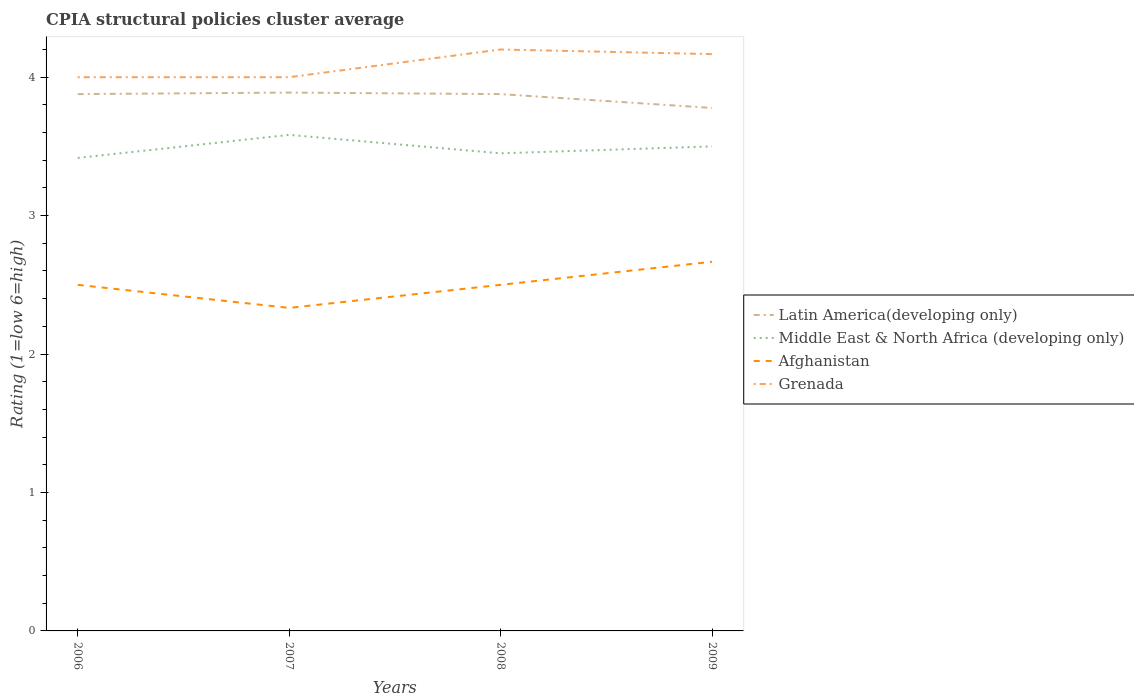How many different coloured lines are there?
Provide a short and direct response. 4. Is the number of lines equal to the number of legend labels?
Ensure brevity in your answer.  Yes. Across all years, what is the maximum CPIA rating in Grenada?
Make the answer very short. 4. In which year was the CPIA rating in Grenada maximum?
Your answer should be very brief. 2006. What is the total CPIA rating in Grenada in the graph?
Your answer should be very brief. -0.17. What is the difference between the highest and the second highest CPIA rating in Grenada?
Ensure brevity in your answer.  0.2. How many lines are there?
Your response must be concise. 4. Are the values on the major ticks of Y-axis written in scientific E-notation?
Offer a terse response. No. Does the graph contain grids?
Provide a succinct answer. No. How many legend labels are there?
Your answer should be compact. 4. How are the legend labels stacked?
Provide a short and direct response. Vertical. What is the title of the graph?
Offer a terse response. CPIA structural policies cluster average. What is the label or title of the X-axis?
Your response must be concise. Years. What is the Rating (1=low 6=high) in Latin America(developing only) in 2006?
Keep it short and to the point. 3.88. What is the Rating (1=low 6=high) in Middle East & North Africa (developing only) in 2006?
Your response must be concise. 3.42. What is the Rating (1=low 6=high) of Grenada in 2006?
Make the answer very short. 4. What is the Rating (1=low 6=high) in Latin America(developing only) in 2007?
Ensure brevity in your answer.  3.89. What is the Rating (1=low 6=high) of Middle East & North Africa (developing only) in 2007?
Your answer should be very brief. 3.58. What is the Rating (1=low 6=high) of Afghanistan in 2007?
Keep it short and to the point. 2.33. What is the Rating (1=low 6=high) in Latin America(developing only) in 2008?
Keep it short and to the point. 3.88. What is the Rating (1=low 6=high) of Middle East & North Africa (developing only) in 2008?
Offer a very short reply. 3.45. What is the Rating (1=low 6=high) of Grenada in 2008?
Provide a short and direct response. 4.2. What is the Rating (1=low 6=high) in Latin America(developing only) in 2009?
Offer a very short reply. 3.78. What is the Rating (1=low 6=high) of Afghanistan in 2009?
Offer a very short reply. 2.67. What is the Rating (1=low 6=high) of Grenada in 2009?
Make the answer very short. 4.17. Across all years, what is the maximum Rating (1=low 6=high) in Latin America(developing only)?
Your response must be concise. 3.89. Across all years, what is the maximum Rating (1=low 6=high) in Middle East & North Africa (developing only)?
Make the answer very short. 3.58. Across all years, what is the maximum Rating (1=low 6=high) in Afghanistan?
Keep it short and to the point. 2.67. Across all years, what is the maximum Rating (1=low 6=high) of Grenada?
Provide a short and direct response. 4.2. Across all years, what is the minimum Rating (1=low 6=high) of Latin America(developing only)?
Your response must be concise. 3.78. Across all years, what is the minimum Rating (1=low 6=high) of Middle East & North Africa (developing only)?
Make the answer very short. 3.42. Across all years, what is the minimum Rating (1=low 6=high) of Afghanistan?
Make the answer very short. 2.33. What is the total Rating (1=low 6=high) of Latin America(developing only) in the graph?
Offer a terse response. 15.42. What is the total Rating (1=low 6=high) in Middle East & North Africa (developing only) in the graph?
Your answer should be compact. 13.95. What is the total Rating (1=low 6=high) of Afghanistan in the graph?
Provide a short and direct response. 10. What is the total Rating (1=low 6=high) in Grenada in the graph?
Offer a very short reply. 16.37. What is the difference between the Rating (1=low 6=high) of Latin America(developing only) in 2006 and that in 2007?
Provide a short and direct response. -0.01. What is the difference between the Rating (1=low 6=high) in Middle East & North Africa (developing only) in 2006 and that in 2007?
Your response must be concise. -0.17. What is the difference between the Rating (1=low 6=high) in Latin America(developing only) in 2006 and that in 2008?
Your response must be concise. 0. What is the difference between the Rating (1=low 6=high) in Middle East & North Africa (developing only) in 2006 and that in 2008?
Offer a terse response. -0.03. What is the difference between the Rating (1=low 6=high) of Afghanistan in 2006 and that in 2008?
Offer a very short reply. 0. What is the difference between the Rating (1=low 6=high) of Middle East & North Africa (developing only) in 2006 and that in 2009?
Provide a short and direct response. -0.08. What is the difference between the Rating (1=low 6=high) in Afghanistan in 2006 and that in 2009?
Your answer should be very brief. -0.17. What is the difference between the Rating (1=low 6=high) of Latin America(developing only) in 2007 and that in 2008?
Provide a short and direct response. 0.01. What is the difference between the Rating (1=low 6=high) in Middle East & North Africa (developing only) in 2007 and that in 2008?
Make the answer very short. 0.13. What is the difference between the Rating (1=low 6=high) of Grenada in 2007 and that in 2008?
Offer a very short reply. -0.2. What is the difference between the Rating (1=low 6=high) of Middle East & North Africa (developing only) in 2007 and that in 2009?
Provide a succinct answer. 0.08. What is the difference between the Rating (1=low 6=high) in Afghanistan in 2007 and that in 2009?
Make the answer very short. -0.33. What is the difference between the Rating (1=low 6=high) in Middle East & North Africa (developing only) in 2008 and that in 2009?
Provide a short and direct response. -0.05. What is the difference between the Rating (1=low 6=high) of Latin America(developing only) in 2006 and the Rating (1=low 6=high) of Middle East & North Africa (developing only) in 2007?
Your answer should be very brief. 0.29. What is the difference between the Rating (1=low 6=high) of Latin America(developing only) in 2006 and the Rating (1=low 6=high) of Afghanistan in 2007?
Keep it short and to the point. 1.54. What is the difference between the Rating (1=low 6=high) in Latin America(developing only) in 2006 and the Rating (1=low 6=high) in Grenada in 2007?
Give a very brief answer. -0.12. What is the difference between the Rating (1=low 6=high) of Middle East & North Africa (developing only) in 2006 and the Rating (1=low 6=high) of Grenada in 2007?
Provide a succinct answer. -0.58. What is the difference between the Rating (1=low 6=high) of Afghanistan in 2006 and the Rating (1=low 6=high) of Grenada in 2007?
Offer a very short reply. -1.5. What is the difference between the Rating (1=low 6=high) in Latin America(developing only) in 2006 and the Rating (1=low 6=high) in Middle East & North Africa (developing only) in 2008?
Your answer should be compact. 0.43. What is the difference between the Rating (1=low 6=high) of Latin America(developing only) in 2006 and the Rating (1=low 6=high) of Afghanistan in 2008?
Your answer should be compact. 1.38. What is the difference between the Rating (1=low 6=high) in Latin America(developing only) in 2006 and the Rating (1=low 6=high) in Grenada in 2008?
Your response must be concise. -0.32. What is the difference between the Rating (1=low 6=high) of Middle East & North Africa (developing only) in 2006 and the Rating (1=low 6=high) of Afghanistan in 2008?
Make the answer very short. 0.92. What is the difference between the Rating (1=low 6=high) of Middle East & North Africa (developing only) in 2006 and the Rating (1=low 6=high) of Grenada in 2008?
Provide a succinct answer. -0.78. What is the difference between the Rating (1=low 6=high) in Latin America(developing only) in 2006 and the Rating (1=low 6=high) in Middle East & North Africa (developing only) in 2009?
Provide a short and direct response. 0.38. What is the difference between the Rating (1=low 6=high) in Latin America(developing only) in 2006 and the Rating (1=low 6=high) in Afghanistan in 2009?
Your answer should be compact. 1.21. What is the difference between the Rating (1=low 6=high) in Latin America(developing only) in 2006 and the Rating (1=low 6=high) in Grenada in 2009?
Make the answer very short. -0.29. What is the difference between the Rating (1=low 6=high) of Middle East & North Africa (developing only) in 2006 and the Rating (1=low 6=high) of Grenada in 2009?
Your answer should be compact. -0.75. What is the difference between the Rating (1=low 6=high) of Afghanistan in 2006 and the Rating (1=low 6=high) of Grenada in 2009?
Offer a very short reply. -1.67. What is the difference between the Rating (1=low 6=high) in Latin America(developing only) in 2007 and the Rating (1=low 6=high) in Middle East & North Africa (developing only) in 2008?
Provide a succinct answer. 0.44. What is the difference between the Rating (1=low 6=high) of Latin America(developing only) in 2007 and the Rating (1=low 6=high) of Afghanistan in 2008?
Provide a succinct answer. 1.39. What is the difference between the Rating (1=low 6=high) of Latin America(developing only) in 2007 and the Rating (1=low 6=high) of Grenada in 2008?
Ensure brevity in your answer.  -0.31. What is the difference between the Rating (1=low 6=high) of Middle East & North Africa (developing only) in 2007 and the Rating (1=low 6=high) of Grenada in 2008?
Your answer should be very brief. -0.62. What is the difference between the Rating (1=low 6=high) of Afghanistan in 2007 and the Rating (1=low 6=high) of Grenada in 2008?
Your answer should be compact. -1.87. What is the difference between the Rating (1=low 6=high) of Latin America(developing only) in 2007 and the Rating (1=low 6=high) of Middle East & North Africa (developing only) in 2009?
Your answer should be compact. 0.39. What is the difference between the Rating (1=low 6=high) of Latin America(developing only) in 2007 and the Rating (1=low 6=high) of Afghanistan in 2009?
Give a very brief answer. 1.22. What is the difference between the Rating (1=low 6=high) of Latin America(developing only) in 2007 and the Rating (1=low 6=high) of Grenada in 2009?
Offer a very short reply. -0.28. What is the difference between the Rating (1=low 6=high) of Middle East & North Africa (developing only) in 2007 and the Rating (1=low 6=high) of Grenada in 2009?
Your answer should be compact. -0.58. What is the difference between the Rating (1=low 6=high) in Afghanistan in 2007 and the Rating (1=low 6=high) in Grenada in 2009?
Offer a very short reply. -1.83. What is the difference between the Rating (1=low 6=high) of Latin America(developing only) in 2008 and the Rating (1=low 6=high) of Middle East & North Africa (developing only) in 2009?
Your response must be concise. 0.38. What is the difference between the Rating (1=low 6=high) of Latin America(developing only) in 2008 and the Rating (1=low 6=high) of Afghanistan in 2009?
Provide a succinct answer. 1.21. What is the difference between the Rating (1=low 6=high) in Latin America(developing only) in 2008 and the Rating (1=low 6=high) in Grenada in 2009?
Your answer should be very brief. -0.29. What is the difference between the Rating (1=low 6=high) of Middle East & North Africa (developing only) in 2008 and the Rating (1=low 6=high) of Afghanistan in 2009?
Your answer should be compact. 0.78. What is the difference between the Rating (1=low 6=high) in Middle East & North Africa (developing only) in 2008 and the Rating (1=low 6=high) in Grenada in 2009?
Your answer should be very brief. -0.72. What is the difference between the Rating (1=low 6=high) in Afghanistan in 2008 and the Rating (1=low 6=high) in Grenada in 2009?
Provide a succinct answer. -1.67. What is the average Rating (1=low 6=high) of Latin America(developing only) per year?
Offer a very short reply. 3.86. What is the average Rating (1=low 6=high) of Middle East & North Africa (developing only) per year?
Offer a terse response. 3.49. What is the average Rating (1=low 6=high) of Grenada per year?
Give a very brief answer. 4.09. In the year 2006, what is the difference between the Rating (1=low 6=high) in Latin America(developing only) and Rating (1=low 6=high) in Middle East & North Africa (developing only)?
Give a very brief answer. 0.46. In the year 2006, what is the difference between the Rating (1=low 6=high) of Latin America(developing only) and Rating (1=low 6=high) of Afghanistan?
Provide a short and direct response. 1.38. In the year 2006, what is the difference between the Rating (1=low 6=high) of Latin America(developing only) and Rating (1=low 6=high) of Grenada?
Provide a short and direct response. -0.12. In the year 2006, what is the difference between the Rating (1=low 6=high) of Middle East & North Africa (developing only) and Rating (1=low 6=high) of Afghanistan?
Provide a short and direct response. 0.92. In the year 2006, what is the difference between the Rating (1=low 6=high) of Middle East & North Africa (developing only) and Rating (1=low 6=high) of Grenada?
Provide a succinct answer. -0.58. In the year 2006, what is the difference between the Rating (1=low 6=high) in Afghanistan and Rating (1=low 6=high) in Grenada?
Make the answer very short. -1.5. In the year 2007, what is the difference between the Rating (1=low 6=high) of Latin America(developing only) and Rating (1=low 6=high) of Middle East & North Africa (developing only)?
Your answer should be compact. 0.31. In the year 2007, what is the difference between the Rating (1=low 6=high) in Latin America(developing only) and Rating (1=low 6=high) in Afghanistan?
Your answer should be very brief. 1.56. In the year 2007, what is the difference between the Rating (1=low 6=high) in Latin America(developing only) and Rating (1=low 6=high) in Grenada?
Your answer should be compact. -0.11. In the year 2007, what is the difference between the Rating (1=low 6=high) of Middle East & North Africa (developing only) and Rating (1=low 6=high) of Grenada?
Your answer should be very brief. -0.42. In the year 2007, what is the difference between the Rating (1=low 6=high) in Afghanistan and Rating (1=low 6=high) in Grenada?
Provide a succinct answer. -1.67. In the year 2008, what is the difference between the Rating (1=low 6=high) of Latin America(developing only) and Rating (1=low 6=high) of Middle East & North Africa (developing only)?
Offer a very short reply. 0.43. In the year 2008, what is the difference between the Rating (1=low 6=high) of Latin America(developing only) and Rating (1=low 6=high) of Afghanistan?
Provide a succinct answer. 1.38. In the year 2008, what is the difference between the Rating (1=low 6=high) of Latin America(developing only) and Rating (1=low 6=high) of Grenada?
Ensure brevity in your answer.  -0.32. In the year 2008, what is the difference between the Rating (1=low 6=high) in Middle East & North Africa (developing only) and Rating (1=low 6=high) in Afghanistan?
Give a very brief answer. 0.95. In the year 2008, what is the difference between the Rating (1=low 6=high) of Middle East & North Africa (developing only) and Rating (1=low 6=high) of Grenada?
Give a very brief answer. -0.75. In the year 2008, what is the difference between the Rating (1=low 6=high) of Afghanistan and Rating (1=low 6=high) of Grenada?
Your answer should be very brief. -1.7. In the year 2009, what is the difference between the Rating (1=low 6=high) in Latin America(developing only) and Rating (1=low 6=high) in Middle East & North Africa (developing only)?
Your response must be concise. 0.28. In the year 2009, what is the difference between the Rating (1=low 6=high) in Latin America(developing only) and Rating (1=low 6=high) in Grenada?
Make the answer very short. -0.39. In the year 2009, what is the difference between the Rating (1=low 6=high) of Afghanistan and Rating (1=low 6=high) of Grenada?
Your response must be concise. -1.5. What is the ratio of the Rating (1=low 6=high) of Middle East & North Africa (developing only) in 2006 to that in 2007?
Ensure brevity in your answer.  0.95. What is the ratio of the Rating (1=low 6=high) in Afghanistan in 2006 to that in 2007?
Your answer should be very brief. 1.07. What is the ratio of the Rating (1=low 6=high) in Grenada in 2006 to that in 2007?
Ensure brevity in your answer.  1. What is the ratio of the Rating (1=low 6=high) in Middle East & North Africa (developing only) in 2006 to that in 2008?
Your response must be concise. 0.99. What is the ratio of the Rating (1=low 6=high) of Grenada in 2006 to that in 2008?
Offer a terse response. 0.95. What is the ratio of the Rating (1=low 6=high) in Latin America(developing only) in 2006 to that in 2009?
Keep it short and to the point. 1.03. What is the ratio of the Rating (1=low 6=high) in Middle East & North Africa (developing only) in 2006 to that in 2009?
Give a very brief answer. 0.98. What is the ratio of the Rating (1=low 6=high) in Grenada in 2006 to that in 2009?
Give a very brief answer. 0.96. What is the ratio of the Rating (1=low 6=high) in Middle East & North Africa (developing only) in 2007 to that in 2008?
Give a very brief answer. 1.04. What is the ratio of the Rating (1=low 6=high) of Grenada in 2007 to that in 2008?
Your response must be concise. 0.95. What is the ratio of the Rating (1=low 6=high) of Latin America(developing only) in 2007 to that in 2009?
Provide a short and direct response. 1.03. What is the ratio of the Rating (1=low 6=high) of Middle East & North Africa (developing only) in 2007 to that in 2009?
Your answer should be very brief. 1.02. What is the ratio of the Rating (1=low 6=high) of Afghanistan in 2007 to that in 2009?
Give a very brief answer. 0.88. What is the ratio of the Rating (1=low 6=high) in Latin America(developing only) in 2008 to that in 2009?
Provide a short and direct response. 1.03. What is the ratio of the Rating (1=low 6=high) of Middle East & North Africa (developing only) in 2008 to that in 2009?
Make the answer very short. 0.99. What is the ratio of the Rating (1=low 6=high) in Afghanistan in 2008 to that in 2009?
Provide a short and direct response. 0.94. What is the ratio of the Rating (1=low 6=high) in Grenada in 2008 to that in 2009?
Your answer should be very brief. 1.01. What is the difference between the highest and the second highest Rating (1=low 6=high) in Latin America(developing only)?
Provide a short and direct response. 0.01. What is the difference between the highest and the second highest Rating (1=low 6=high) in Middle East & North Africa (developing only)?
Your response must be concise. 0.08. What is the difference between the highest and the lowest Rating (1=low 6=high) in Latin America(developing only)?
Provide a succinct answer. 0.11. What is the difference between the highest and the lowest Rating (1=low 6=high) in Middle East & North Africa (developing only)?
Give a very brief answer. 0.17. What is the difference between the highest and the lowest Rating (1=low 6=high) in Afghanistan?
Give a very brief answer. 0.33. What is the difference between the highest and the lowest Rating (1=low 6=high) of Grenada?
Your answer should be very brief. 0.2. 